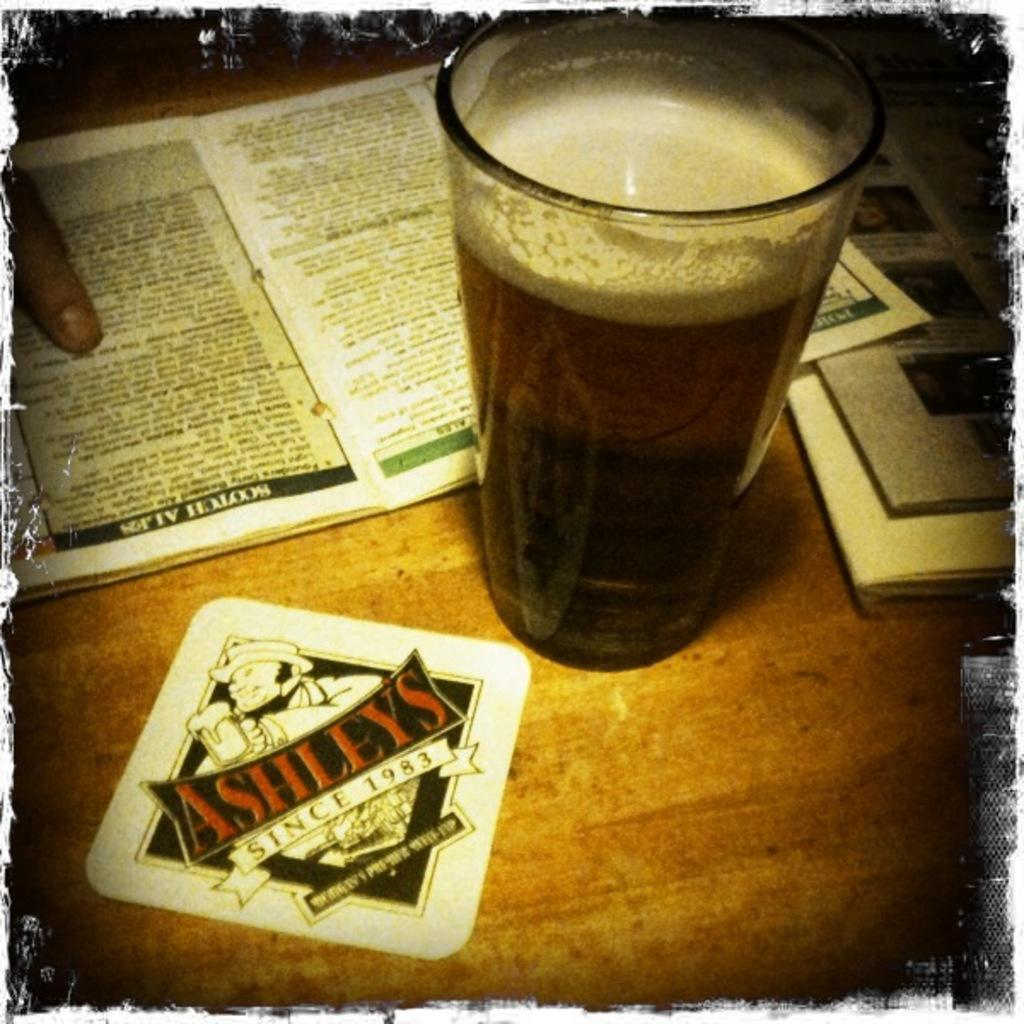What is the color of the table in the image? The table in the image is brown colored. What objects can be seen on the table? There are books and a glass with liquid in the image. Can you identify any body parts in the image? Yes, a human finger is visible in the image. What is in the glass on the table? There is a glass with liquid on the table. How does the beam of light affect the soda in the image? There is no beam of light present in the image, and therefore no effect on the soda can be observed. 